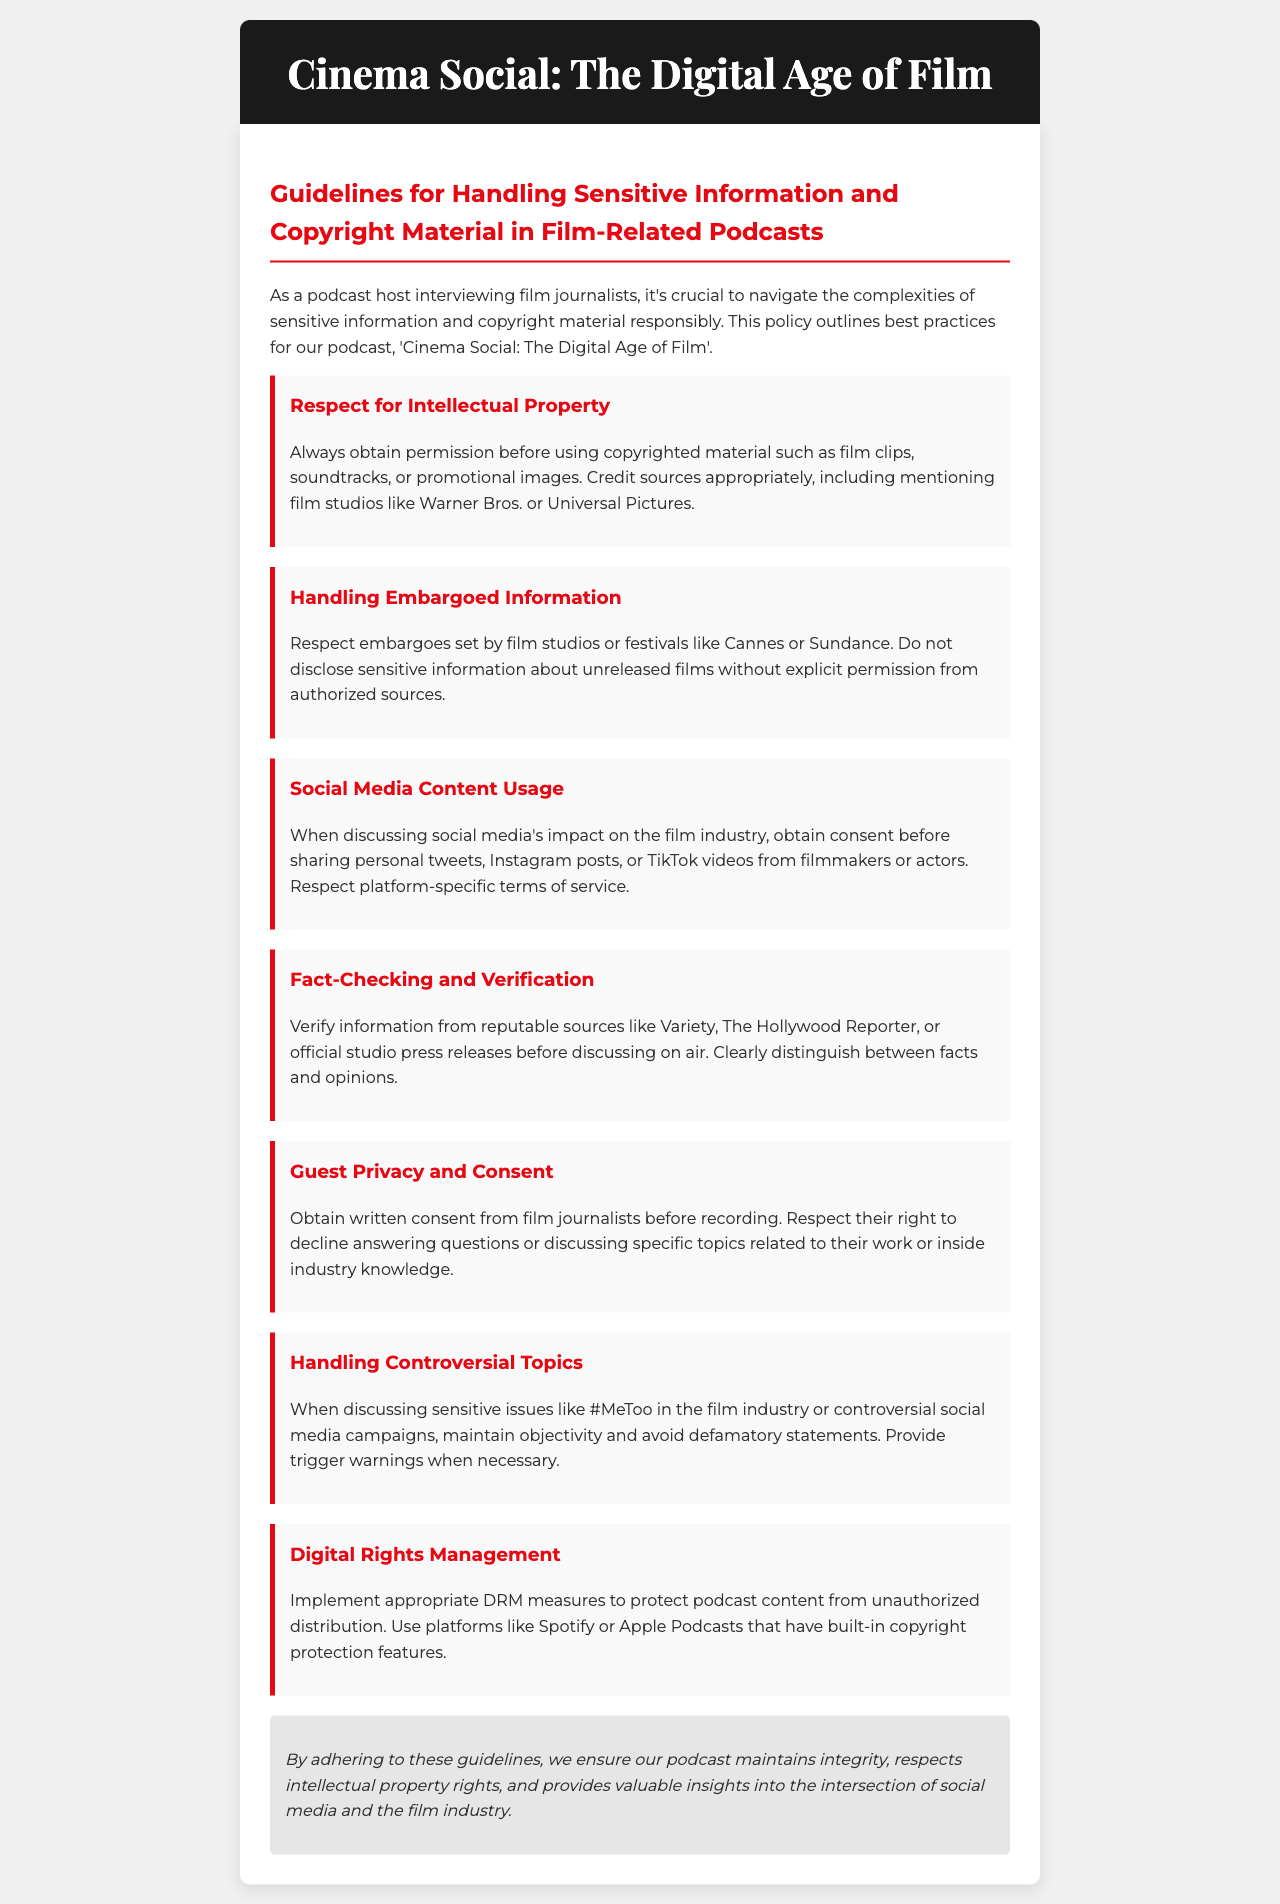What is the title of the policy document? The title is the main heading of the document, which indicates its subject.
Answer: Cinema Social: The Digital Age of Film What should be obtained before using copyrighted material? This detail specifies a requirement for handling intellectual property.
Answer: Permission Name one film festival mentioned in the guidelines. This requires recalling specific examples provided in the document.
Answer: Cannes What is required before discussing social media content? This is a reference to responsible practices highlighted in the document.
Answer: Consent According to the document, which type of information must be verified? This requires identifying the nature of information to be validated before discussion.
Answer: Information What is a recommended action when discussing sensitive issues? The document provides guidance on how to handle controversial topics respectfully.
Answer: Maintain objectivity How should guest privacy be protected? This elaborates on practices related to interviewing film journalists.
Answer: Written consent What does DRM stand for in the context of this document? This abbreviated term is explained within the guidelines related to podcast content.
Answer: Digital Rights Management Name one reputable source for fact-checking information. This question seeks to identify sources recommended for verifying claims.
Answer: Variety 